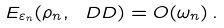<formula> <loc_0><loc_0><loc_500><loc_500>E _ { \varepsilon _ { n } } ( \rho _ { n } , \ D D ) = O ( \omega _ { n } ) \, .</formula> 